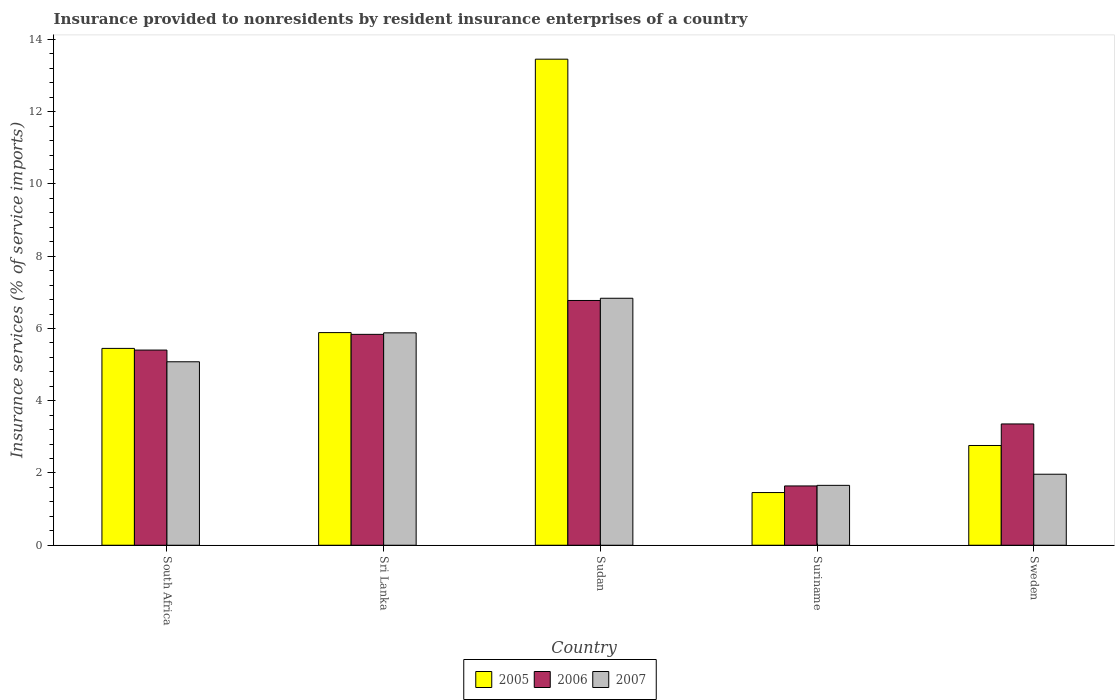How many groups of bars are there?
Provide a short and direct response. 5. Are the number of bars per tick equal to the number of legend labels?
Offer a terse response. Yes. What is the label of the 4th group of bars from the left?
Give a very brief answer. Suriname. In how many cases, is the number of bars for a given country not equal to the number of legend labels?
Make the answer very short. 0. What is the insurance provided to nonresidents in 2005 in South Africa?
Your response must be concise. 5.45. Across all countries, what is the maximum insurance provided to nonresidents in 2005?
Your answer should be very brief. 13.46. Across all countries, what is the minimum insurance provided to nonresidents in 2006?
Offer a very short reply. 1.64. In which country was the insurance provided to nonresidents in 2007 maximum?
Give a very brief answer. Sudan. In which country was the insurance provided to nonresidents in 2007 minimum?
Your answer should be very brief. Suriname. What is the total insurance provided to nonresidents in 2005 in the graph?
Your response must be concise. 29.01. What is the difference between the insurance provided to nonresidents in 2005 in Sri Lanka and that in Sweden?
Offer a very short reply. 3.13. What is the difference between the insurance provided to nonresidents in 2007 in Sri Lanka and the insurance provided to nonresidents in 2005 in Suriname?
Provide a short and direct response. 4.42. What is the average insurance provided to nonresidents in 2006 per country?
Your response must be concise. 4.6. What is the difference between the insurance provided to nonresidents of/in 2007 and insurance provided to nonresidents of/in 2006 in Sri Lanka?
Provide a succinct answer. 0.04. What is the ratio of the insurance provided to nonresidents in 2007 in Sri Lanka to that in Sudan?
Make the answer very short. 0.86. What is the difference between the highest and the second highest insurance provided to nonresidents in 2006?
Offer a terse response. -0.43. What is the difference between the highest and the lowest insurance provided to nonresidents in 2005?
Ensure brevity in your answer.  12. In how many countries, is the insurance provided to nonresidents in 2007 greater than the average insurance provided to nonresidents in 2007 taken over all countries?
Make the answer very short. 3. Is the sum of the insurance provided to nonresidents in 2007 in South Africa and Suriname greater than the maximum insurance provided to nonresidents in 2005 across all countries?
Make the answer very short. No. What does the 3rd bar from the left in Suriname represents?
Provide a short and direct response. 2007. Is it the case that in every country, the sum of the insurance provided to nonresidents in 2006 and insurance provided to nonresidents in 2005 is greater than the insurance provided to nonresidents in 2007?
Your response must be concise. Yes. How many bars are there?
Offer a terse response. 15. What is the difference between two consecutive major ticks on the Y-axis?
Make the answer very short. 2. Where does the legend appear in the graph?
Your answer should be very brief. Bottom center. How many legend labels are there?
Offer a terse response. 3. What is the title of the graph?
Your response must be concise. Insurance provided to nonresidents by resident insurance enterprises of a country. Does "1991" appear as one of the legend labels in the graph?
Your response must be concise. No. What is the label or title of the Y-axis?
Your response must be concise. Insurance services (% of service imports). What is the Insurance services (% of service imports) in 2005 in South Africa?
Offer a very short reply. 5.45. What is the Insurance services (% of service imports) of 2006 in South Africa?
Provide a succinct answer. 5.4. What is the Insurance services (% of service imports) of 2007 in South Africa?
Keep it short and to the point. 5.08. What is the Insurance services (% of service imports) of 2005 in Sri Lanka?
Your response must be concise. 5.89. What is the Insurance services (% of service imports) in 2006 in Sri Lanka?
Provide a succinct answer. 5.84. What is the Insurance services (% of service imports) in 2007 in Sri Lanka?
Make the answer very short. 5.88. What is the Insurance services (% of service imports) in 2005 in Sudan?
Ensure brevity in your answer.  13.46. What is the Insurance services (% of service imports) in 2006 in Sudan?
Offer a terse response. 6.78. What is the Insurance services (% of service imports) in 2007 in Sudan?
Make the answer very short. 6.84. What is the Insurance services (% of service imports) in 2005 in Suriname?
Make the answer very short. 1.46. What is the Insurance services (% of service imports) in 2006 in Suriname?
Your answer should be compact. 1.64. What is the Insurance services (% of service imports) of 2007 in Suriname?
Offer a very short reply. 1.66. What is the Insurance services (% of service imports) of 2005 in Sweden?
Make the answer very short. 2.76. What is the Insurance services (% of service imports) in 2006 in Sweden?
Offer a terse response. 3.36. What is the Insurance services (% of service imports) in 2007 in Sweden?
Provide a short and direct response. 1.97. Across all countries, what is the maximum Insurance services (% of service imports) in 2005?
Make the answer very short. 13.46. Across all countries, what is the maximum Insurance services (% of service imports) of 2006?
Give a very brief answer. 6.78. Across all countries, what is the maximum Insurance services (% of service imports) of 2007?
Make the answer very short. 6.84. Across all countries, what is the minimum Insurance services (% of service imports) in 2005?
Provide a short and direct response. 1.46. Across all countries, what is the minimum Insurance services (% of service imports) of 2006?
Your answer should be very brief. 1.64. Across all countries, what is the minimum Insurance services (% of service imports) of 2007?
Your answer should be very brief. 1.66. What is the total Insurance services (% of service imports) in 2005 in the graph?
Keep it short and to the point. 29.01. What is the total Insurance services (% of service imports) in 2006 in the graph?
Provide a short and direct response. 23.01. What is the total Insurance services (% of service imports) of 2007 in the graph?
Ensure brevity in your answer.  21.42. What is the difference between the Insurance services (% of service imports) of 2005 in South Africa and that in Sri Lanka?
Your answer should be compact. -0.44. What is the difference between the Insurance services (% of service imports) in 2006 in South Africa and that in Sri Lanka?
Ensure brevity in your answer.  -0.43. What is the difference between the Insurance services (% of service imports) in 2007 in South Africa and that in Sri Lanka?
Your response must be concise. -0.8. What is the difference between the Insurance services (% of service imports) in 2005 in South Africa and that in Sudan?
Ensure brevity in your answer.  -8.01. What is the difference between the Insurance services (% of service imports) of 2006 in South Africa and that in Sudan?
Offer a terse response. -1.37. What is the difference between the Insurance services (% of service imports) of 2007 in South Africa and that in Sudan?
Ensure brevity in your answer.  -1.76. What is the difference between the Insurance services (% of service imports) in 2005 in South Africa and that in Suriname?
Provide a succinct answer. 3.99. What is the difference between the Insurance services (% of service imports) in 2006 in South Africa and that in Suriname?
Offer a very short reply. 3.76. What is the difference between the Insurance services (% of service imports) of 2007 in South Africa and that in Suriname?
Provide a short and direct response. 3.42. What is the difference between the Insurance services (% of service imports) in 2005 in South Africa and that in Sweden?
Your answer should be compact. 2.69. What is the difference between the Insurance services (% of service imports) of 2006 in South Africa and that in Sweden?
Provide a succinct answer. 2.04. What is the difference between the Insurance services (% of service imports) in 2007 in South Africa and that in Sweden?
Ensure brevity in your answer.  3.11. What is the difference between the Insurance services (% of service imports) of 2005 in Sri Lanka and that in Sudan?
Keep it short and to the point. -7.57. What is the difference between the Insurance services (% of service imports) in 2006 in Sri Lanka and that in Sudan?
Your response must be concise. -0.94. What is the difference between the Insurance services (% of service imports) in 2007 in Sri Lanka and that in Sudan?
Your answer should be very brief. -0.96. What is the difference between the Insurance services (% of service imports) of 2005 in Sri Lanka and that in Suriname?
Ensure brevity in your answer.  4.43. What is the difference between the Insurance services (% of service imports) of 2006 in Sri Lanka and that in Suriname?
Ensure brevity in your answer.  4.2. What is the difference between the Insurance services (% of service imports) of 2007 in Sri Lanka and that in Suriname?
Make the answer very short. 4.22. What is the difference between the Insurance services (% of service imports) in 2005 in Sri Lanka and that in Sweden?
Provide a succinct answer. 3.13. What is the difference between the Insurance services (% of service imports) in 2006 in Sri Lanka and that in Sweden?
Provide a succinct answer. 2.48. What is the difference between the Insurance services (% of service imports) of 2007 in Sri Lanka and that in Sweden?
Keep it short and to the point. 3.91. What is the difference between the Insurance services (% of service imports) in 2005 in Sudan and that in Suriname?
Your answer should be very brief. 12. What is the difference between the Insurance services (% of service imports) in 2006 in Sudan and that in Suriname?
Provide a succinct answer. 5.13. What is the difference between the Insurance services (% of service imports) in 2007 in Sudan and that in Suriname?
Give a very brief answer. 5.18. What is the difference between the Insurance services (% of service imports) of 2005 in Sudan and that in Sweden?
Keep it short and to the point. 10.69. What is the difference between the Insurance services (% of service imports) in 2006 in Sudan and that in Sweden?
Keep it short and to the point. 3.42. What is the difference between the Insurance services (% of service imports) of 2007 in Sudan and that in Sweden?
Provide a succinct answer. 4.87. What is the difference between the Insurance services (% of service imports) of 2005 in Suriname and that in Sweden?
Give a very brief answer. -1.3. What is the difference between the Insurance services (% of service imports) of 2006 in Suriname and that in Sweden?
Keep it short and to the point. -1.72. What is the difference between the Insurance services (% of service imports) in 2007 in Suriname and that in Sweden?
Make the answer very short. -0.31. What is the difference between the Insurance services (% of service imports) of 2005 in South Africa and the Insurance services (% of service imports) of 2006 in Sri Lanka?
Provide a succinct answer. -0.39. What is the difference between the Insurance services (% of service imports) in 2005 in South Africa and the Insurance services (% of service imports) in 2007 in Sri Lanka?
Ensure brevity in your answer.  -0.43. What is the difference between the Insurance services (% of service imports) of 2006 in South Africa and the Insurance services (% of service imports) of 2007 in Sri Lanka?
Make the answer very short. -0.48. What is the difference between the Insurance services (% of service imports) of 2005 in South Africa and the Insurance services (% of service imports) of 2006 in Sudan?
Your response must be concise. -1.33. What is the difference between the Insurance services (% of service imports) of 2005 in South Africa and the Insurance services (% of service imports) of 2007 in Sudan?
Offer a very short reply. -1.39. What is the difference between the Insurance services (% of service imports) of 2006 in South Africa and the Insurance services (% of service imports) of 2007 in Sudan?
Offer a terse response. -1.43. What is the difference between the Insurance services (% of service imports) of 2005 in South Africa and the Insurance services (% of service imports) of 2006 in Suriname?
Offer a terse response. 3.81. What is the difference between the Insurance services (% of service imports) in 2005 in South Africa and the Insurance services (% of service imports) in 2007 in Suriname?
Your answer should be very brief. 3.79. What is the difference between the Insurance services (% of service imports) of 2006 in South Africa and the Insurance services (% of service imports) of 2007 in Suriname?
Your answer should be very brief. 3.75. What is the difference between the Insurance services (% of service imports) in 2005 in South Africa and the Insurance services (% of service imports) in 2006 in Sweden?
Your answer should be very brief. 2.09. What is the difference between the Insurance services (% of service imports) of 2005 in South Africa and the Insurance services (% of service imports) of 2007 in Sweden?
Give a very brief answer. 3.48. What is the difference between the Insurance services (% of service imports) of 2006 in South Africa and the Insurance services (% of service imports) of 2007 in Sweden?
Provide a short and direct response. 3.44. What is the difference between the Insurance services (% of service imports) of 2005 in Sri Lanka and the Insurance services (% of service imports) of 2006 in Sudan?
Make the answer very short. -0.89. What is the difference between the Insurance services (% of service imports) in 2005 in Sri Lanka and the Insurance services (% of service imports) in 2007 in Sudan?
Ensure brevity in your answer.  -0.95. What is the difference between the Insurance services (% of service imports) of 2006 in Sri Lanka and the Insurance services (% of service imports) of 2007 in Sudan?
Provide a short and direct response. -1. What is the difference between the Insurance services (% of service imports) of 2005 in Sri Lanka and the Insurance services (% of service imports) of 2006 in Suriname?
Give a very brief answer. 4.24. What is the difference between the Insurance services (% of service imports) of 2005 in Sri Lanka and the Insurance services (% of service imports) of 2007 in Suriname?
Ensure brevity in your answer.  4.23. What is the difference between the Insurance services (% of service imports) of 2006 in Sri Lanka and the Insurance services (% of service imports) of 2007 in Suriname?
Your response must be concise. 4.18. What is the difference between the Insurance services (% of service imports) of 2005 in Sri Lanka and the Insurance services (% of service imports) of 2006 in Sweden?
Your answer should be very brief. 2.53. What is the difference between the Insurance services (% of service imports) of 2005 in Sri Lanka and the Insurance services (% of service imports) of 2007 in Sweden?
Your answer should be compact. 3.92. What is the difference between the Insurance services (% of service imports) of 2006 in Sri Lanka and the Insurance services (% of service imports) of 2007 in Sweden?
Your answer should be very brief. 3.87. What is the difference between the Insurance services (% of service imports) in 2005 in Sudan and the Insurance services (% of service imports) in 2006 in Suriname?
Provide a succinct answer. 11.81. What is the difference between the Insurance services (% of service imports) in 2005 in Sudan and the Insurance services (% of service imports) in 2007 in Suriname?
Provide a succinct answer. 11.8. What is the difference between the Insurance services (% of service imports) of 2006 in Sudan and the Insurance services (% of service imports) of 2007 in Suriname?
Ensure brevity in your answer.  5.12. What is the difference between the Insurance services (% of service imports) of 2005 in Sudan and the Insurance services (% of service imports) of 2006 in Sweden?
Give a very brief answer. 10.1. What is the difference between the Insurance services (% of service imports) in 2005 in Sudan and the Insurance services (% of service imports) in 2007 in Sweden?
Ensure brevity in your answer.  11.49. What is the difference between the Insurance services (% of service imports) in 2006 in Sudan and the Insurance services (% of service imports) in 2007 in Sweden?
Offer a very short reply. 4.81. What is the difference between the Insurance services (% of service imports) of 2005 in Suriname and the Insurance services (% of service imports) of 2006 in Sweden?
Keep it short and to the point. -1.9. What is the difference between the Insurance services (% of service imports) in 2005 in Suriname and the Insurance services (% of service imports) in 2007 in Sweden?
Offer a terse response. -0.51. What is the difference between the Insurance services (% of service imports) of 2006 in Suriname and the Insurance services (% of service imports) of 2007 in Sweden?
Your answer should be compact. -0.32. What is the average Insurance services (% of service imports) in 2005 per country?
Offer a very short reply. 5.8. What is the average Insurance services (% of service imports) in 2006 per country?
Your response must be concise. 4.6. What is the average Insurance services (% of service imports) in 2007 per country?
Your response must be concise. 4.28. What is the difference between the Insurance services (% of service imports) of 2005 and Insurance services (% of service imports) of 2006 in South Africa?
Make the answer very short. 0.05. What is the difference between the Insurance services (% of service imports) of 2005 and Insurance services (% of service imports) of 2007 in South Africa?
Provide a succinct answer. 0.37. What is the difference between the Insurance services (% of service imports) of 2006 and Insurance services (% of service imports) of 2007 in South Africa?
Give a very brief answer. 0.32. What is the difference between the Insurance services (% of service imports) of 2005 and Insurance services (% of service imports) of 2006 in Sri Lanka?
Offer a terse response. 0.05. What is the difference between the Insurance services (% of service imports) in 2005 and Insurance services (% of service imports) in 2007 in Sri Lanka?
Provide a succinct answer. 0.01. What is the difference between the Insurance services (% of service imports) of 2006 and Insurance services (% of service imports) of 2007 in Sri Lanka?
Offer a very short reply. -0.04. What is the difference between the Insurance services (% of service imports) in 2005 and Insurance services (% of service imports) in 2006 in Sudan?
Your answer should be very brief. 6.68. What is the difference between the Insurance services (% of service imports) of 2005 and Insurance services (% of service imports) of 2007 in Sudan?
Make the answer very short. 6.62. What is the difference between the Insurance services (% of service imports) in 2006 and Insurance services (% of service imports) in 2007 in Sudan?
Keep it short and to the point. -0.06. What is the difference between the Insurance services (% of service imports) in 2005 and Insurance services (% of service imports) in 2006 in Suriname?
Ensure brevity in your answer.  -0.18. What is the difference between the Insurance services (% of service imports) in 2005 and Insurance services (% of service imports) in 2007 in Suriname?
Provide a short and direct response. -0.2. What is the difference between the Insurance services (% of service imports) in 2006 and Insurance services (% of service imports) in 2007 in Suriname?
Ensure brevity in your answer.  -0.02. What is the difference between the Insurance services (% of service imports) in 2005 and Insurance services (% of service imports) in 2006 in Sweden?
Your answer should be very brief. -0.6. What is the difference between the Insurance services (% of service imports) of 2005 and Insurance services (% of service imports) of 2007 in Sweden?
Provide a succinct answer. 0.8. What is the difference between the Insurance services (% of service imports) of 2006 and Insurance services (% of service imports) of 2007 in Sweden?
Offer a very short reply. 1.39. What is the ratio of the Insurance services (% of service imports) in 2005 in South Africa to that in Sri Lanka?
Make the answer very short. 0.93. What is the ratio of the Insurance services (% of service imports) of 2006 in South Africa to that in Sri Lanka?
Offer a terse response. 0.93. What is the ratio of the Insurance services (% of service imports) of 2007 in South Africa to that in Sri Lanka?
Your response must be concise. 0.86. What is the ratio of the Insurance services (% of service imports) in 2005 in South Africa to that in Sudan?
Ensure brevity in your answer.  0.41. What is the ratio of the Insurance services (% of service imports) of 2006 in South Africa to that in Sudan?
Your answer should be compact. 0.8. What is the ratio of the Insurance services (% of service imports) of 2007 in South Africa to that in Sudan?
Make the answer very short. 0.74. What is the ratio of the Insurance services (% of service imports) of 2005 in South Africa to that in Suriname?
Keep it short and to the point. 3.74. What is the ratio of the Insurance services (% of service imports) of 2006 in South Africa to that in Suriname?
Provide a short and direct response. 3.29. What is the ratio of the Insurance services (% of service imports) of 2007 in South Africa to that in Suriname?
Your response must be concise. 3.06. What is the ratio of the Insurance services (% of service imports) of 2005 in South Africa to that in Sweden?
Ensure brevity in your answer.  1.97. What is the ratio of the Insurance services (% of service imports) of 2006 in South Africa to that in Sweden?
Offer a terse response. 1.61. What is the ratio of the Insurance services (% of service imports) of 2007 in South Africa to that in Sweden?
Keep it short and to the point. 2.58. What is the ratio of the Insurance services (% of service imports) in 2005 in Sri Lanka to that in Sudan?
Keep it short and to the point. 0.44. What is the ratio of the Insurance services (% of service imports) of 2006 in Sri Lanka to that in Sudan?
Offer a terse response. 0.86. What is the ratio of the Insurance services (% of service imports) of 2007 in Sri Lanka to that in Sudan?
Give a very brief answer. 0.86. What is the ratio of the Insurance services (% of service imports) of 2005 in Sri Lanka to that in Suriname?
Ensure brevity in your answer.  4.04. What is the ratio of the Insurance services (% of service imports) of 2006 in Sri Lanka to that in Suriname?
Provide a short and direct response. 3.56. What is the ratio of the Insurance services (% of service imports) in 2007 in Sri Lanka to that in Suriname?
Ensure brevity in your answer.  3.55. What is the ratio of the Insurance services (% of service imports) of 2005 in Sri Lanka to that in Sweden?
Provide a short and direct response. 2.13. What is the ratio of the Insurance services (% of service imports) of 2006 in Sri Lanka to that in Sweden?
Your response must be concise. 1.74. What is the ratio of the Insurance services (% of service imports) in 2007 in Sri Lanka to that in Sweden?
Keep it short and to the point. 2.99. What is the ratio of the Insurance services (% of service imports) in 2005 in Sudan to that in Suriname?
Your response must be concise. 9.23. What is the ratio of the Insurance services (% of service imports) in 2006 in Sudan to that in Suriname?
Your answer should be compact. 4.13. What is the ratio of the Insurance services (% of service imports) in 2007 in Sudan to that in Suriname?
Make the answer very short. 4.12. What is the ratio of the Insurance services (% of service imports) of 2005 in Sudan to that in Sweden?
Keep it short and to the point. 4.87. What is the ratio of the Insurance services (% of service imports) in 2006 in Sudan to that in Sweden?
Offer a very short reply. 2.02. What is the ratio of the Insurance services (% of service imports) in 2007 in Sudan to that in Sweden?
Provide a succinct answer. 3.48. What is the ratio of the Insurance services (% of service imports) of 2005 in Suriname to that in Sweden?
Offer a terse response. 0.53. What is the ratio of the Insurance services (% of service imports) in 2006 in Suriname to that in Sweden?
Offer a terse response. 0.49. What is the ratio of the Insurance services (% of service imports) of 2007 in Suriname to that in Sweden?
Your response must be concise. 0.84. What is the difference between the highest and the second highest Insurance services (% of service imports) of 2005?
Provide a succinct answer. 7.57. What is the difference between the highest and the second highest Insurance services (% of service imports) in 2006?
Ensure brevity in your answer.  0.94. What is the difference between the highest and the second highest Insurance services (% of service imports) in 2007?
Provide a succinct answer. 0.96. What is the difference between the highest and the lowest Insurance services (% of service imports) of 2005?
Offer a terse response. 12. What is the difference between the highest and the lowest Insurance services (% of service imports) in 2006?
Make the answer very short. 5.13. What is the difference between the highest and the lowest Insurance services (% of service imports) of 2007?
Give a very brief answer. 5.18. 